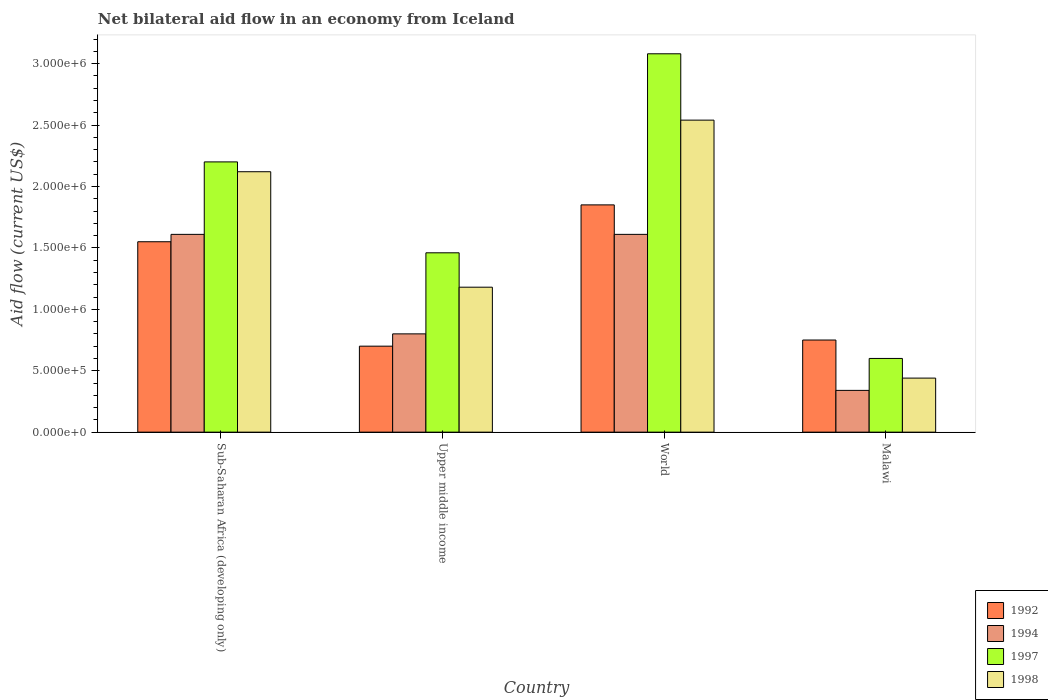How many bars are there on the 2nd tick from the left?
Offer a very short reply. 4. What is the label of the 4th group of bars from the left?
Keep it short and to the point. Malawi. What is the net bilateral aid flow in 1997 in Upper middle income?
Your answer should be very brief. 1.46e+06. Across all countries, what is the maximum net bilateral aid flow in 1994?
Your response must be concise. 1.61e+06. In which country was the net bilateral aid flow in 1992 maximum?
Keep it short and to the point. World. In which country was the net bilateral aid flow in 1997 minimum?
Your answer should be compact. Malawi. What is the total net bilateral aid flow in 1997 in the graph?
Provide a short and direct response. 7.34e+06. What is the difference between the net bilateral aid flow in 1997 in Malawi and that in Sub-Saharan Africa (developing only)?
Your answer should be compact. -1.60e+06. What is the difference between the net bilateral aid flow in 1998 in World and the net bilateral aid flow in 1994 in Upper middle income?
Provide a short and direct response. 1.74e+06. What is the average net bilateral aid flow in 1998 per country?
Your answer should be very brief. 1.57e+06. What is the difference between the net bilateral aid flow of/in 1992 and net bilateral aid flow of/in 1997 in Upper middle income?
Keep it short and to the point. -7.60e+05. What is the ratio of the net bilateral aid flow in 1992 in Sub-Saharan Africa (developing only) to that in World?
Offer a terse response. 0.84. What is the difference between the highest and the second highest net bilateral aid flow in 1998?
Give a very brief answer. 4.20e+05. What is the difference between the highest and the lowest net bilateral aid flow in 1992?
Ensure brevity in your answer.  1.15e+06. Is the sum of the net bilateral aid flow in 1994 in Malawi and Upper middle income greater than the maximum net bilateral aid flow in 1992 across all countries?
Your answer should be compact. No. Is it the case that in every country, the sum of the net bilateral aid flow in 1994 and net bilateral aid flow in 1997 is greater than the net bilateral aid flow in 1998?
Offer a terse response. Yes. How many bars are there?
Provide a short and direct response. 16. Are the values on the major ticks of Y-axis written in scientific E-notation?
Your response must be concise. Yes. Does the graph contain grids?
Keep it short and to the point. No. Where does the legend appear in the graph?
Your response must be concise. Bottom right. What is the title of the graph?
Your answer should be compact. Net bilateral aid flow in an economy from Iceland. What is the Aid flow (current US$) of 1992 in Sub-Saharan Africa (developing only)?
Offer a very short reply. 1.55e+06. What is the Aid flow (current US$) of 1994 in Sub-Saharan Africa (developing only)?
Your answer should be very brief. 1.61e+06. What is the Aid flow (current US$) of 1997 in Sub-Saharan Africa (developing only)?
Provide a short and direct response. 2.20e+06. What is the Aid flow (current US$) of 1998 in Sub-Saharan Africa (developing only)?
Offer a terse response. 2.12e+06. What is the Aid flow (current US$) in 1992 in Upper middle income?
Offer a terse response. 7.00e+05. What is the Aid flow (current US$) in 1994 in Upper middle income?
Keep it short and to the point. 8.00e+05. What is the Aid flow (current US$) of 1997 in Upper middle income?
Offer a very short reply. 1.46e+06. What is the Aid flow (current US$) of 1998 in Upper middle income?
Provide a succinct answer. 1.18e+06. What is the Aid flow (current US$) of 1992 in World?
Offer a very short reply. 1.85e+06. What is the Aid flow (current US$) of 1994 in World?
Make the answer very short. 1.61e+06. What is the Aid flow (current US$) of 1997 in World?
Provide a short and direct response. 3.08e+06. What is the Aid flow (current US$) of 1998 in World?
Provide a short and direct response. 2.54e+06. What is the Aid flow (current US$) in 1992 in Malawi?
Offer a very short reply. 7.50e+05. What is the Aid flow (current US$) of 1994 in Malawi?
Provide a succinct answer. 3.40e+05. What is the Aid flow (current US$) of 1997 in Malawi?
Keep it short and to the point. 6.00e+05. What is the Aid flow (current US$) in 1998 in Malawi?
Make the answer very short. 4.40e+05. Across all countries, what is the maximum Aid flow (current US$) in 1992?
Make the answer very short. 1.85e+06. Across all countries, what is the maximum Aid flow (current US$) of 1994?
Your response must be concise. 1.61e+06. Across all countries, what is the maximum Aid flow (current US$) of 1997?
Keep it short and to the point. 3.08e+06. Across all countries, what is the maximum Aid flow (current US$) in 1998?
Provide a succinct answer. 2.54e+06. Across all countries, what is the minimum Aid flow (current US$) of 1992?
Provide a short and direct response. 7.00e+05. Across all countries, what is the minimum Aid flow (current US$) in 1994?
Give a very brief answer. 3.40e+05. What is the total Aid flow (current US$) in 1992 in the graph?
Ensure brevity in your answer.  4.85e+06. What is the total Aid flow (current US$) in 1994 in the graph?
Your answer should be very brief. 4.36e+06. What is the total Aid flow (current US$) of 1997 in the graph?
Make the answer very short. 7.34e+06. What is the total Aid flow (current US$) of 1998 in the graph?
Make the answer very short. 6.28e+06. What is the difference between the Aid flow (current US$) in 1992 in Sub-Saharan Africa (developing only) and that in Upper middle income?
Provide a succinct answer. 8.50e+05. What is the difference between the Aid flow (current US$) of 1994 in Sub-Saharan Africa (developing only) and that in Upper middle income?
Your response must be concise. 8.10e+05. What is the difference between the Aid flow (current US$) of 1997 in Sub-Saharan Africa (developing only) and that in Upper middle income?
Your response must be concise. 7.40e+05. What is the difference between the Aid flow (current US$) of 1998 in Sub-Saharan Africa (developing only) and that in Upper middle income?
Ensure brevity in your answer.  9.40e+05. What is the difference between the Aid flow (current US$) in 1997 in Sub-Saharan Africa (developing only) and that in World?
Make the answer very short. -8.80e+05. What is the difference between the Aid flow (current US$) in 1998 in Sub-Saharan Africa (developing only) and that in World?
Offer a very short reply. -4.20e+05. What is the difference between the Aid flow (current US$) in 1994 in Sub-Saharan Africa (developing only) and that in Malawi?
Offer a very short reply. 1.27e+06. What is the difference between the Aid flow (current US$) of 1997 in Sub-Saharan Africa (developing only) and that in Malawi?
Keep it short and to the point. 1.60e+06. What is the difference between the Aid flow (current US$) in 1998 in Sub-Saharan Africa (developing only) and that in Malawi?
Keep it short and to the point. 1.68e+06. What is the difference between the Aid flow (current US$) in 1992 in Upper middle income and that in World?
Keep it short and to the point. -1.15e+06. What is the difference between the Aid flow (current US$) in 1994 in Upper middle income and that in World?
Provide a succinct answer. -8.10e+05. What is the difference between the Aid flow (current US$) in 1997 in Upper middle income and that in World?
Your response must be concise. -1.62e+06. What is the difference between the Aid flow (current US$) in 1998 in Upper middle income and that in World?
Keep it short and to the point. -1.36e+06. What is the difference between the Aid flow (current US$) in 1994 in Upper middle income and that in Malawi?
Keep it short and to the point. 4.60e+05. What is the difference between the Aid flow (current US$) in 1997 in Upper middle income and that in Malawi?
Provide a short and direct response. 8.60e+05. What is the difference between the Aid flow (current US$) in 1998 in Upper middle income and that in Malawi?
Make the answer very short. 7.40e+05. What is the difference between the Aid flow (current US$) in 1992 in World and that in Malawi?
Offer a terse response. 1.10e+06. What is the difference between the Aid flow (current US$) in 1994 in World and that in Malawi?
Your response must be concise. 1.27e+06. What is the difference between the Aid flow (current US$) in 1997 in World and that in Malawi?
Give a very brief answer. 2.48e+06. What is the difference between the Aid flow (current US$) of 1998 in World and that in Malawi?
Your response must be concise. 2.10e+06. What is the difference between the Aid flow (current US$) of 1992 in Sub-Saharan Africa (developing only) and the Aid flow (current US$) of 1994 in Upper middle income?
Give a very brief answer. 7.50e+05. What is the difference between the Aid flow (current US$) in 1992 in Sub-Saharan Africa (developing only) and the Aid flow (current US$) in 1997 in Upper middle income?
Provide a short and direct response. 9.00e+04. What is the difference between the Aid flow (current US$) in 1997 in Sub-Saharan Africa (developing only) and the Aid flow (current US$) in 1998 in Upper middle income?
Your response must be concise. 1.02e+06. What is the difference between the Aid flow (current US$) of 1992 in Sub-Saharan Africa (developing only) and the Aid flow (current US$) of 1994 in World?
Offer a very short reply. -6.00e+04. What is the difference between the Aid flow (current US$) in 1992 in Sub-Saharan Africa (developing only) and the Aid flow (current US$) in 1997 in World?
Make the answer very short. -1.53e+06. What is the difference between the Aid flow (current US$) of 1992 in Sub-Saharan Africa (developing only) and the Aid flow (current US$) of 1998 in World?
Keep it short and to the point. -9.90e+05. What is the difference between the Aid flow (current US$) in 1994 in Sub-Saharan Africa (developing only) and the Aid flow (current US$) in 1997 in World?
Offer a very short reply. -1.47e+06. What is the difference between the Aid flow (current US$) in 1994 in Sub-Saharan Africa (developing only) and the Aid flow (current US$) in 1998 in World?
Keep it short and to the point. -9.30e+05. What is the difference between the Aid flow (current US$) in 1997 in Sub-Saharan Africa (developing only) and the Aid flow (current US$) in 1998 in World?
Your answer should be compact. -3.40e+05. What is the difference between the Aid flow (current US$) of 1992 in Sub-Saharan Africa (developing only) and the Aid flow (current US$) of 1994 in Malawi?
Offer a very short reply. 1.21e+06. What is the difference between the Aid flow (current US$) in 1992 in Sub-Saharan Africa (developing only) and the Aid flow (current US$) in 1997 in Malawi?
Your answer should be compact. 9.50e+05. What is the difference between the Aid flow (current US$) in 1992 in Sub-Saharan Africa (developing only) and the Aid flow (current US$) in 1998 in Malawi?
Your answer should be very brief. 1.11e+06. What is the difference between the Aid flow (current US$) in 1994 in Sub-Saharan Africa (developing only) and the Aid flow (current US$) in 1997 in Malawi?
Your answer should be compact. 1.01e+06. What is the difference between the Aid flow (current US$) of 1994 in Sub-Saharan Africa (developing only) and the Aid flow (current US$) of 1998 in Malawi?
Your answer should be compact. 1.17e+06. What is the difference between the Aid flow (current US$) in 1997 in Sub-Saharan Africa (developing only) and the Aid flow (current US$) in 1998 in Malawi?
Your answer should be very brief. 1.76e+06. What is the difference between the Aid flow (current US$) of 1992 in Upper middle income and the Aid flow (current US$) of 1994 in World?
Your response must be concise. -9.10e+05. What is the difference between the Aid flow (current US$) in 1992 in Upper middle income and the Aid flow (current US$) in 1997 in World?
Your answer should be compact. -2.38e+06. What is the difference between the Aid flow (current US$) of 1992 in Upper middle income and the Aid flow (current US$) of 1998 in World?
Offer a very short reply. -1.84e+06. What is the difference between the Aid flow (current US$) in 1994 in Upper middle income and the Aid flow (current US$) in 1997 in World?
Provide a short and direct response. -2.28e+06. What is the difference between the Aid flow (current US$) of 1994 in Upper middle income and the Aid flow (current US$) of 1998 in World?
Offer a terse response. -1.74e+06. What is the difference between the Aid flow (current US$) in 1997 in Upper middle income and the Aid flow (current US$) in 1998 in World?
Your response must be concise. -1.08e+06. What is the difference between the Aid flow (current US$) of 1992 in Upper middle income and the Aid flow (current US$) of 1994 in Malawi?
Your answer should be very brief. 3.60e+05. What is the difference between the Aid flow (current US$) of 1992 in Upper middle income and the Aid flow (current US$) of 1997 in Malawi?
Your answer should be compact. 1.00e+05. What is the difference between the Aid flow (current US$) of 1997 in Upper middle income and the Aid flow (current US$) of 1998 in Malawi?
Provide a succinct answer. 1.02e+06. What is the difference between the Aid flow (current US$) of 1992 in World and the Aid flow (current US$) of 1994 in Malawi?
Provide a short and direct response. 1.51e+06. What is the difference between the Aid flow (current US$) of 1992 in World and the Aid flow (current US$) of 1997 in Malawi?
Your response must be concise. 1.25e+06. What is the difference between the Aid flow (current US$) of 1992 in World and the Aid flow (current US$) of 1998 in Malawi?
Your answer should be very brief. 1.41e+06. What is the difference between the Aid flow (current US$) of 1994 in World and the Aid flow (current US$) of 1997 in Malawi?
Offer a very short reply. 1.01e+06. What is the difference between the Aid flow (current US$) in 1994 in World and the Aid flow (current US$) in 1998 in Malawi?
Ensure brevity in your answer.  1.17e+06. What is the difference between the Aid flow (current US$) of 1997 in World and the Aid flow (current US$) of 1998 in Malawi?
Offer a terse response. 2.64e+06. What is the average Aid flow (current US$) in 1992 per country?
Keep it short and to the point. 1.21e+06. What is the average Aid flow (current US$) in 1994 per country?
Your answer should be very brief. 1.09e+06. What is the average Aid flow (current US$) of 1997 per country?
Offer a terse response. 1.84e+06. What is the average Aid flow (current US$) in 1998 per country?
Offer a very short reply. 1.57e+06. What is the difference between the Aid flow (current US$) in 1992 and Aid flow (current US$) in 1994 in Sub-Saharan Africa (developing only)?
Provide a succinct answer. -6.00e+04. What is the difference between the Aid flow (current US$) of 1992 and Aid flow (current US$) of 1997 in Sub-Saharan Africa (developing only)?
Ensure brevity in your answer.  -6.50e+05. What is the difference between the Aid flow (current US$) of 1992 and Aid flow (current US$) of 1998 in Sub-Saharan Africa (developing only)?
Keep it short and to the point. -5.70e+05. What is the difference between the Aid flow (current US$) in 1994 and Aid flow (current US$) in 1997 in Sub-Saharan Africa (developing only)?
Offer a terse response. -5.90e+05. What is the difference between the Aid flow (current US$) of 1994 and Aid flow (current US$) of 1998 in Sub-Saharan Africa (developing only)?
Give a very brief answer. -5.10e+05. What is the difference between the Aid flow (current US$) of 1992 and Aid flow (current US$) of 1994 in Upper middle income?
Ensure brevity in your answer.  -1.00e+05. What is the difference between the Aid flow (current US$) of 1992 and Aid flow (current US$) of 1997 in Upper middle income?
Provide a short and direct response. -7.60e+05. What is the difference between the Aid flow (current US$) of 1992 and Aid flow (current US$) of 1998 in Upper middle income?
Your answer should be very brief. -4.80e+05. What is the difference between the Aid flow (current US$) in 1994 and Aid flow (current US$) in 1997 in Upper middle income?
Give a very brief answer. -6.60e+05. What is the difference between the Aid flow (current US$) of 1994 and Aid flow (current US$) of 1998 in Upper middle income?
Your response must be concise. -3.80e+05. What is the difference between the Aid flow (current US$) of 1992 and Aid flow (current US$) of 1997 in World?
Offer a very short reply. -1.23e+06. What is the difference between the Aid flow (current US$) in 1992 and Aid flow (current US$) in 1998 in World?
Give a very brief answer. -6.90e+05. What is the difference between the Aid flow (current US$) of 1994 and Aid flow (current US$) of 1997 in World?
Your response must be concise. -1.47e+06. What is the difference between the Aid flow (current US$) in 1994 and Aid flow (current US$) in 1998 in World?
Make the answer very short. -9.30e+05. What is the difference between the Aid flow (current US$) in 1997 and Aid flow (current US$) in 1998 in World?
Ensure brevity in your answer.  5.40e+05. What is the difference between the Aid flow (current US$) of 1992 and Aid flow (current US$) of 1998 in Malawi?
Offer a very short reply. 3.10e+05. What is the difference between the Aid flow (current US$) of 1994 and Aid flow (current US$) of 1997 in Malawi?
Provide a succinct answer. -2.60e+05. What is the ratio of the Aid flow (current US$) of 1992 in Sub-Saharan Africa (developing only) to that in Upper middle income?
Offer a very short reply. 2.21. What is the ratio of the Aid flow (current US$) of 1994 in Sub-Saharan Africa (developing only) to that in Upper middle income?
Provide a short and direct response. 2.01. What is the ratio of the Aid flow (current US$) of 1997 in Sub-Saharan Africa (developing only) to that in Upper middle income?
Your response must be concise. 1.51. What is the ratio of the Aid flow (current US$) in 1998 in Sub-Saharan Africa (developing only) to that in Upper middle income?
Your response must be concise. 1.8. What is the ratio of the Aid flow (current US$) in 1992 in Sub-Saharan Africa (developing only) to that in World?
Offer a very short reply. 0.84. What is the ratio of the Aid flow (current US$) in 1998 in Sub-Saharan Africa (developing only) to that in World?
Provide a short and direct response. 0.83. What is the ratio of the Aid flow (current US$) of 1992 in Sub-Saharan Africa (developing only) to that in Malawi?
Provide a short and direct response. 2.07. What is the ratio of the Aid flow (current US$) in 1994 in Sub-Saharan Africa (developing only) to that in Malawi?
Provide a succinct answer. 4.74. What is the ratio of the Aid flow (current US$) in 1997 in Sub-Saharan Africa (developing only) to that in Malawi?
Your answer should be compact. 3.67. What is the ratio of the Aid flow (current US$) of 1998 in Sub-Saharan Africa (developing only) to that in Malawi?
Provide a succinct answer. 4.82. What is the ratio of the Aid flow (current US$) in 1992 in Upper middle income to that in World?
Keep it short and to the point. 0.38. What is the ratio of the Aid flow (current US$) in 1994 in Upper middle income to that in World?
Offer a very short reply. 0.5. What is the ratio of the Aid flow (current US$) in 1997 in Upper middle income to that in World?
Make the answer very short. 0.47. What is the ratio of the Aid flow (current US$) in 1998 in Upper middle income to that in World?
Offer a terse response. 0.46. What is the ratio of the Aid flow (current US$) in 1992 in Upper middle income to that in Malawi?
Provide a succinct answer. 0.93. What is the ratio of the Aid flow (current US$) in 1994 in Upper middle income to that in Malawi?
Give a very brief answer. 2.35. What is the ratio of the Aid flow (current US$) in 1997 in Upper middle income to that in Malawi?
Keep it short and to the point. 2.43. What is the ratio of the Aid flow (current US$) in 1998 in Upper middle income to that in Malawi?
Your response must be concise. 2.68. What is the ratio of the Aid flow (current US$) of 1992 in World to that in Malawi?
Provide a short and direct response. 2.47. What is the ratio of the Aid flow (current US$) of 1994 in World to that in Malawi?
Make the answer very short. 4.74. What is the ratio of the Aid flow (current US$) in 1997 in World to that in Malawi?
Provide a succinct answer. 5.13. What is the ratio of the Aid flow (current US$) in 1998 in World to that in Malawi?
Offer a very short reply. 5.77. What is the difference between the highest and the second highest Aid flow (current US$) of 1992?
Provide a succinct answer. 3.00e+05. What is the difference between the highest and the second highest Aid flow (current US$) of 1997?
Make the answer very short. 8.80e+05. What is the difference between the highest and the lowest Aid flow (current US$) of 1992?
Give a very brief answer. 1.15e+06. What is the difference between the highest and the lowest Aid flow (current US$) in 1994?
Offer a terse response. 1.27e+06. What is the difference between the highest and the lowest Aid flow (current US$) of 1997?
Offer a very short reply. 2.48e+06. What is the difference between the highest and the lowest Aid flow (current US$) of 1998?
Keep it short and to the point. 2.10e+06. 